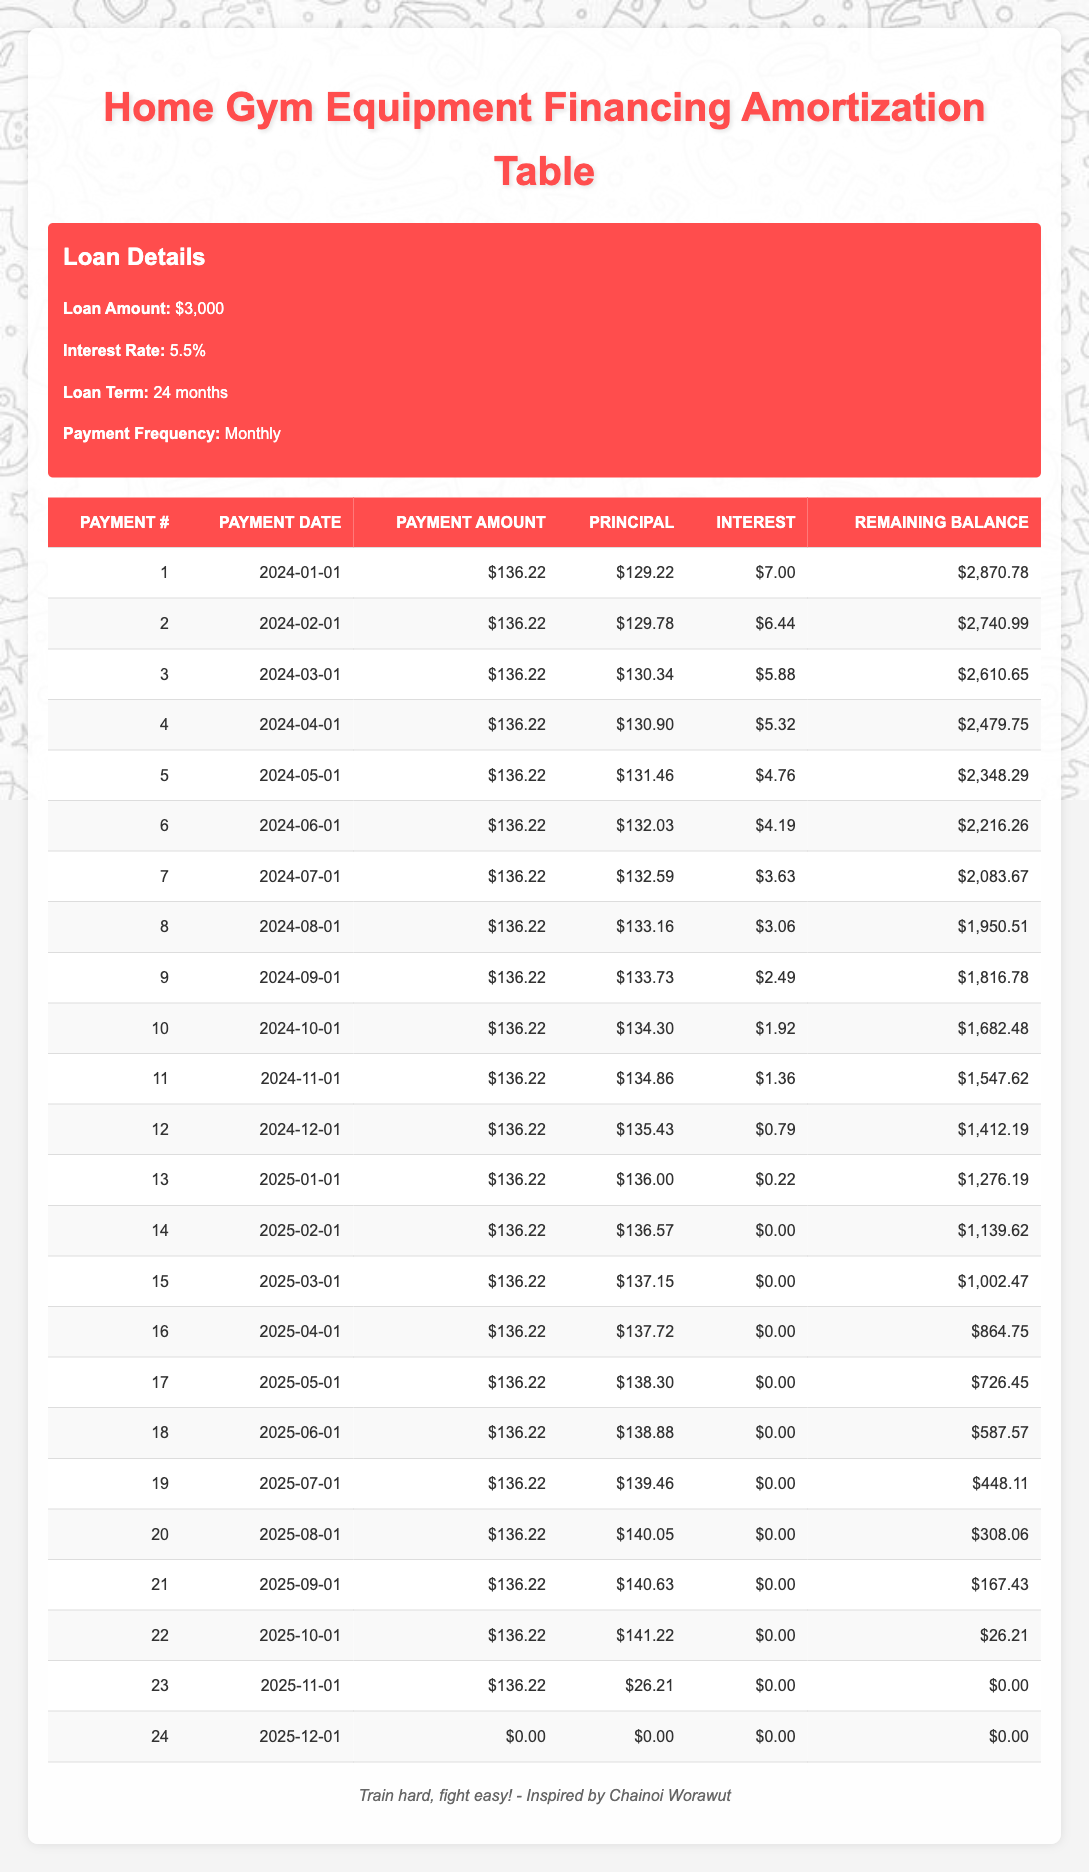What is the total loan amount? The loan details state that the loan amount is $3,000.
Answer: 3000 How much is the monthly payment? Each monthly payment is listed as $136.22 in the table.
Answer: 136.22 What is the total interest paid over the life of the loan? To find the total interest, we sum the interest from all payments: 7.00 + 6.44 + 5.88 + 5.32 + 4.76 + 4.19 + 3.63 + 3.06 + 2.49 + 1.92 + 1.36 + 0.79 + 0.22 + 0 + 0 + 0 + 0 + 0 + 0 + 0 + 0 + 0 + 0 + 0 + 0 = 48.96.
Answer: 48.96 Did the interest ever drop to zero? Yes, by looking at the payments, interest reached zero starting from the 14th payment onward.
Answer: Yes What was the remaining balance after the 12th payment? The remaining balance after the 12th payment is listed as $1,412.19 in the table.
Answer: 1412.19 What is the average principal paid per month? To calculate the average principal paid, we find the total principal paid over the period: sum all principals from each payment and divide by the number of payment months. Total principal is 129.22 + 129.78 + 130.34 + 130.90 + 131.46 + 132.03 + 132.59 + 133.16 + 133.73 + 134.30 + 134.86 + 135.43 + 136.00 + 136.57 + 137.15 + 137.72 + 138.30 + 138.88 + 139.46 + 140.05 + 140.63 + 141.22 + 26.21 = 2,818.04. Thus, the average is 2818.04 / 24 = 117.42.
Answer: 117.42 What payment number had the highest interest? The highest interest payment is the first payment which had $7.00 of interest.
Answer: 1 How much principal is paid off in the last payment? In the last payment (payment 24), the principal paid off is $26.21.
Answer: 26.21 How many payments are required to completely pay off the loan? The loan is paid off after 24 payments since the remaining balance reaches $0 after the 24th payment.
Answer: 24 